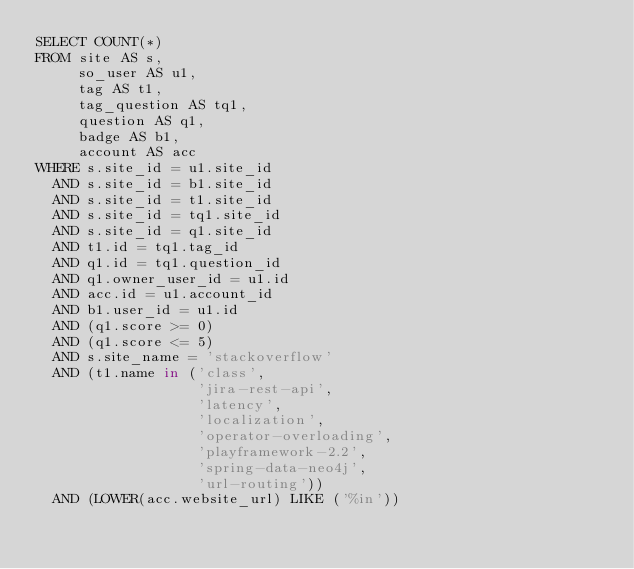<code> <loc_0><loc_0><loc_500><loc_500><_SQL_>SELECT COUNT(*)
FROM site AS s,
     so_user AS u1,
     tag AS t1,
     tag_question AS tq1,
     question AS q1,
     badge AS b1,
     account AS acc
WHERE s.site_id = u1.site_id
  AND s.site_id = b1.site_id
  AND s.site_id = t1.site_id
  AND s.site_id = tq1.site_id
  AND s.site_id = q1.site_id
  AND t1.id = tq1.tag_id
  AND q1.id = tq1.question_id
  AND q1.owner_user_id = u1.id
  AND acc.id = u1.account_id
  AND b1.user_id = u1.id
  AND (q1.score >= 0)
  AND (q1.score <= 5)
  AND s.site_name = 'stackoverflow'
  AND (t1.name in ('class',
                   'jira-rest-api',
                   'latency',
                   'localization',
                   'operator-overloading',
                   'playframework-2.2',
                   'spring-data-neo4j',
                   'url-routing'))
  AND (LOWER(acc.website_url) LIKE ('%in'))</code> 